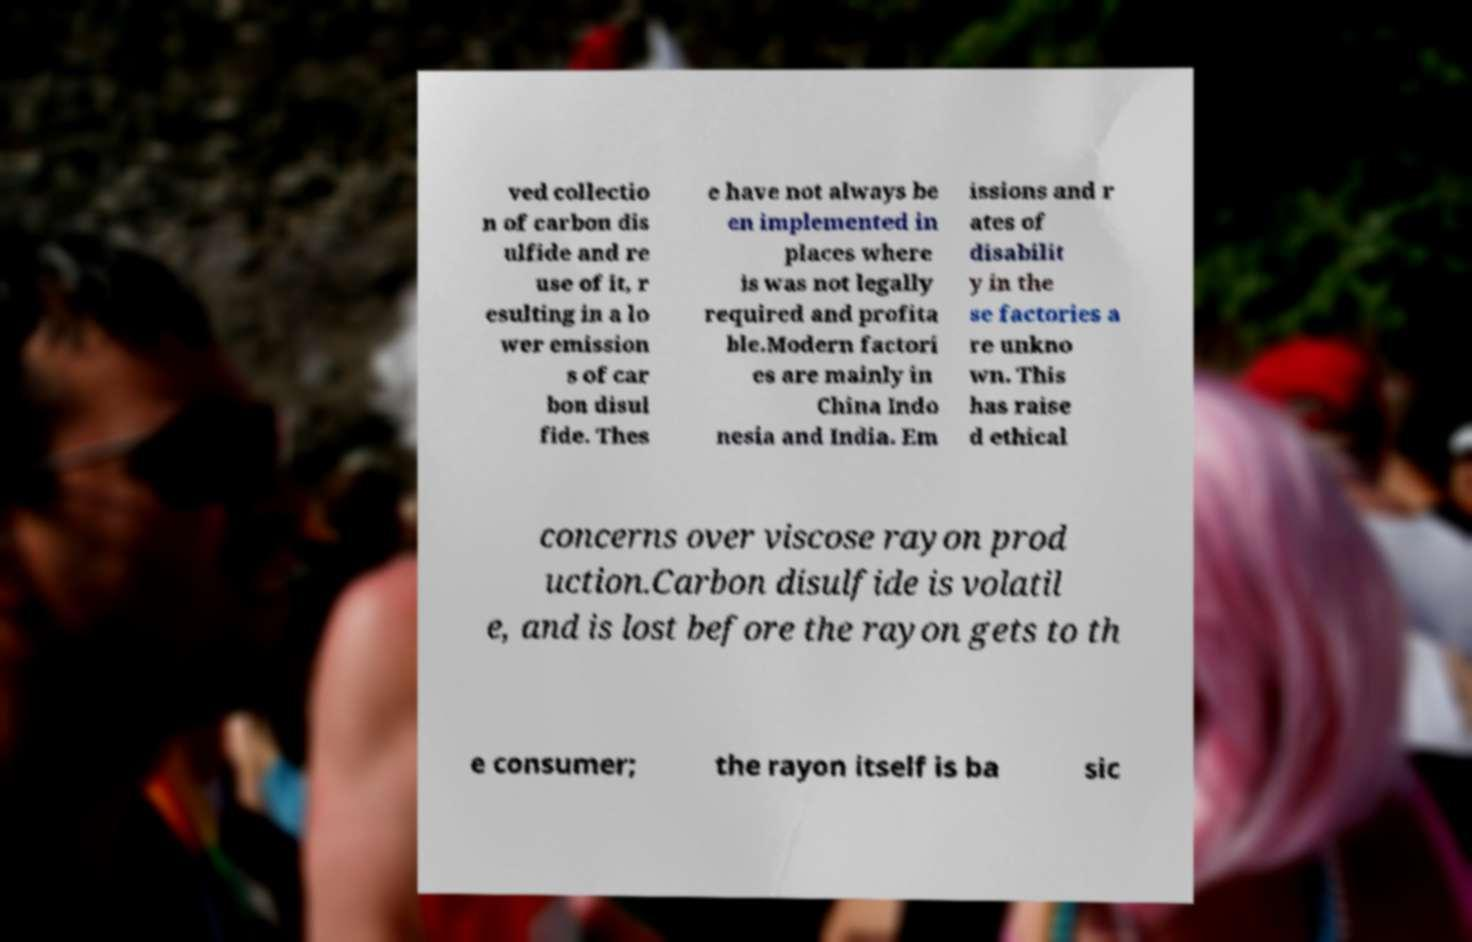Can you accurately transcribe the text from the provided image for me? ved collectio n of carbon dis ulfide and re use of it, r esulting in a lo wer emission s of car bon disul fide. Thes e have not always be en implemented in places where is was not legally required and profita ble.Modern factori es are mainly in China Indo nesia and India. Em issions and r ates of disabilit y in the se factories a re unkno wn. This has raise d ethical concerns over viscose rayon prod uction.Carbon disulfide is volatil e, and is lost before the rayon gets to th e consumer; the rayon itself is ba sic 